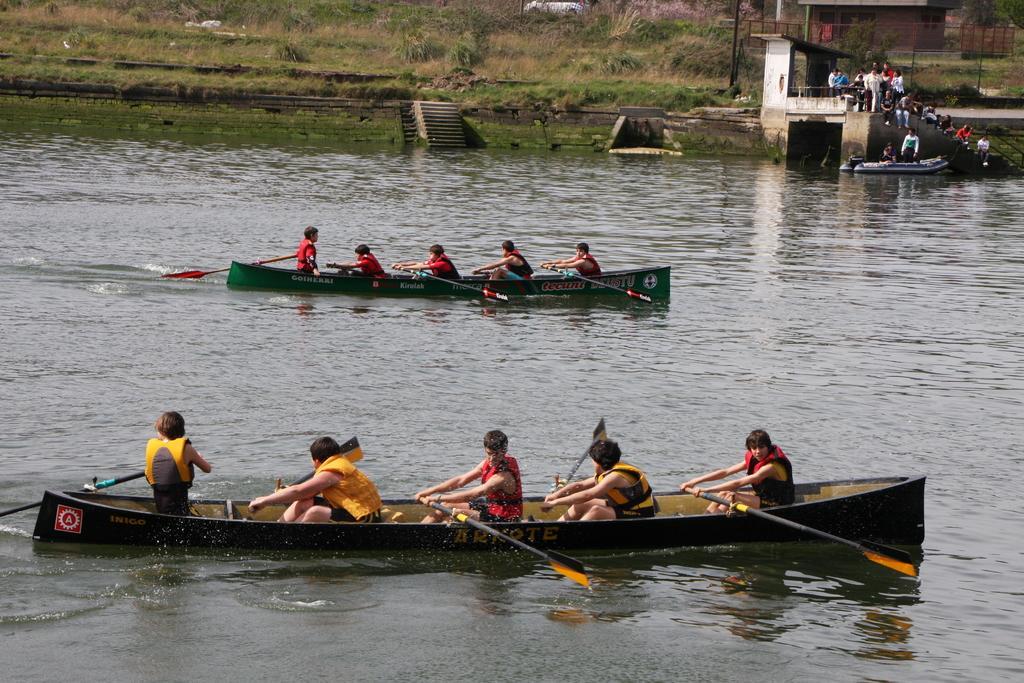Please provide a concise description of this image. In this image we can see many persons sailing on the boat on the water. In the background we can see stairs, persons, grass and plants. 